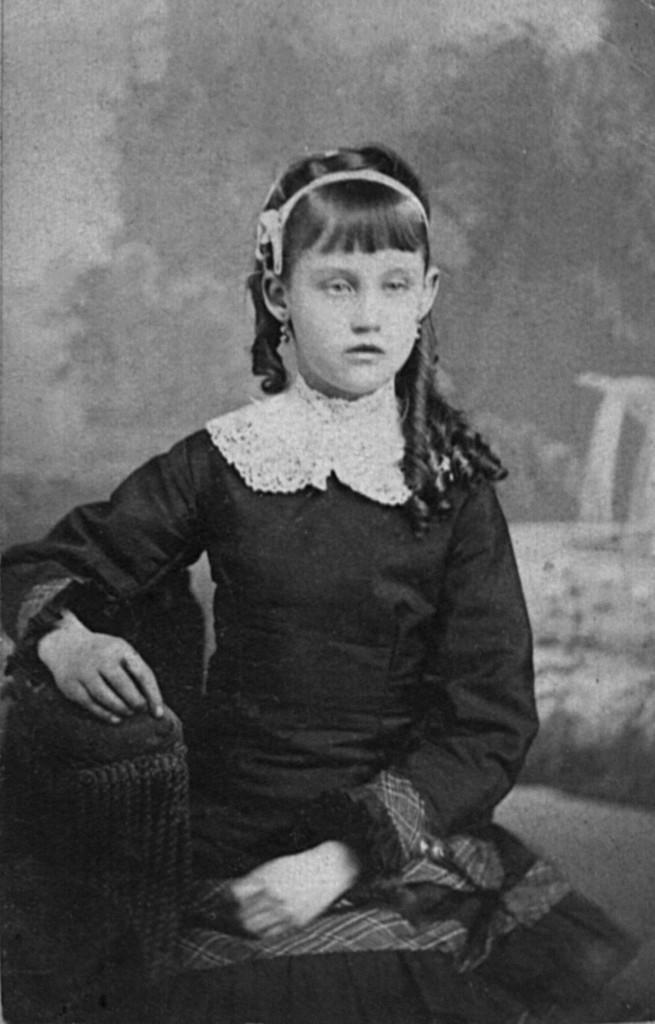How would you summarize this image in a sentence or two? This is a black and white image. In the image there is a girl sitting. 